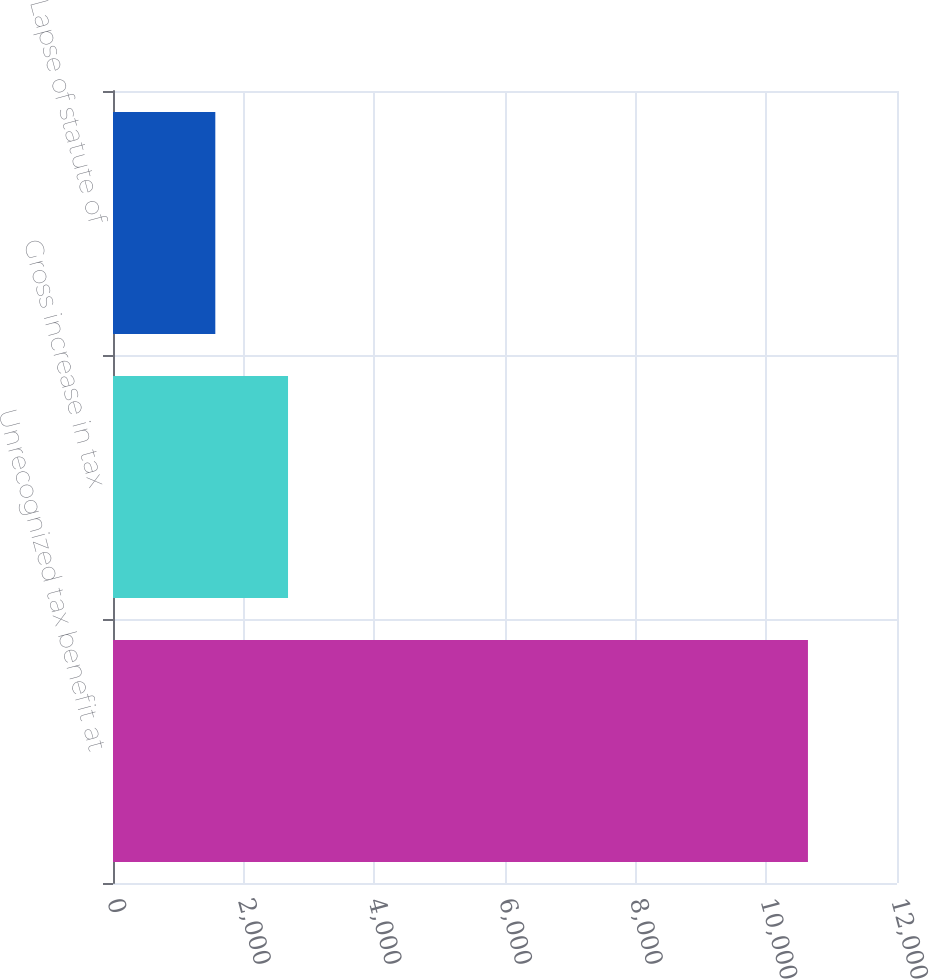Convert chart to OTSL. <chart><loc_0><loc_0><loc_500><loc_500><bar_chart><fcel>Unrecognized tax benefit at<fcel>Gross increase in tax<fcel>Lapse of statute of<nl><fcel>10637<fcel>2679<fcel>1566<nl></chart> 